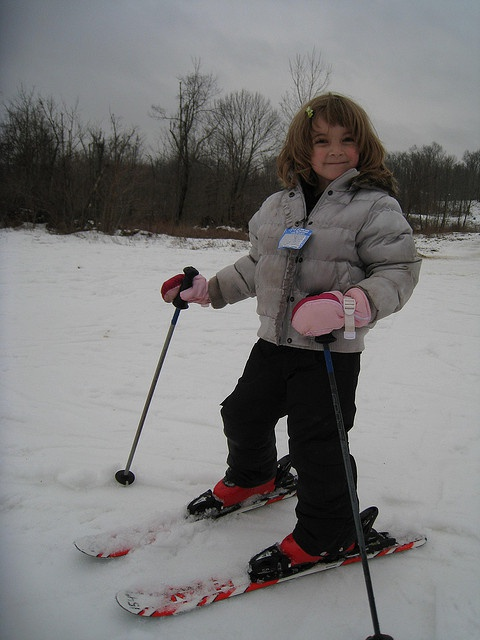Describe the objects in this image and their specific colors. I can see people in gray, black, and maroon tones and skis in gray and black tones in this image. 